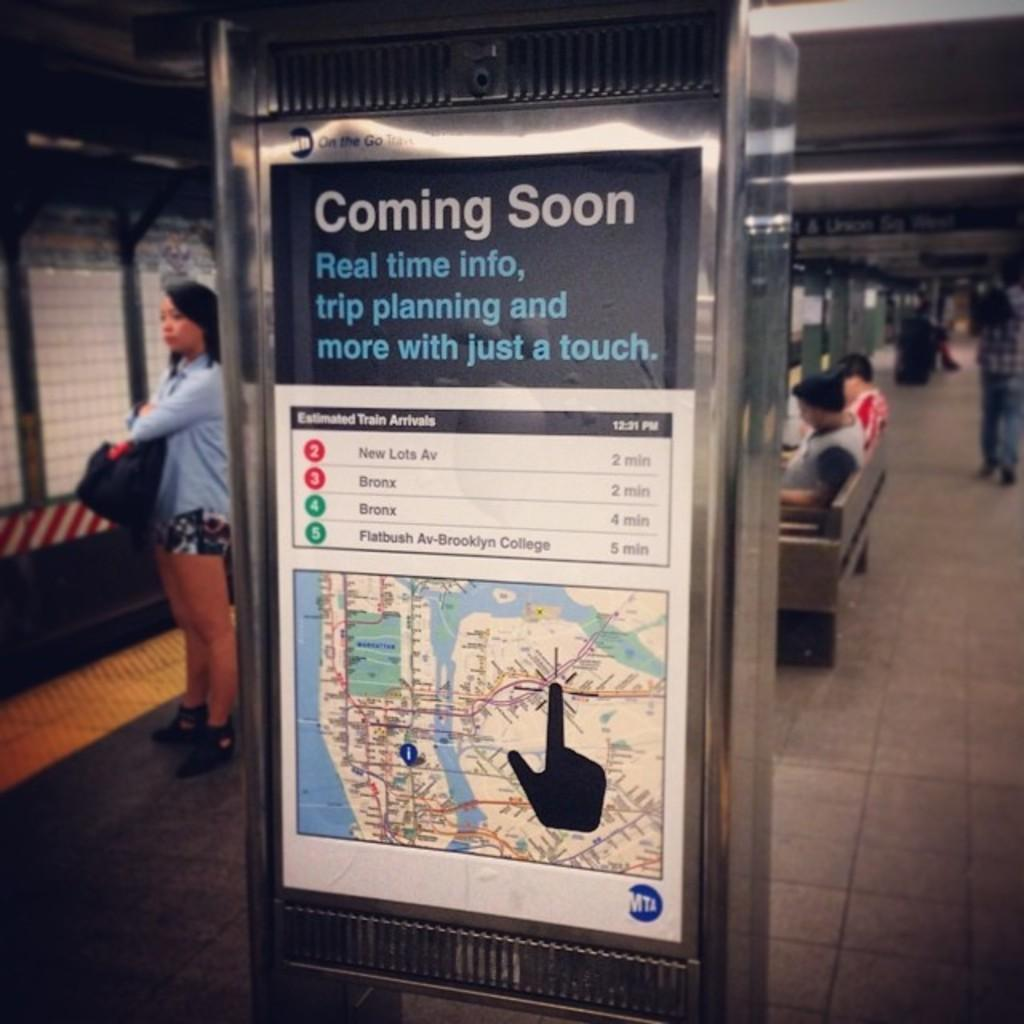<image>
Create a compact narrative representing the image presented. the real time info for the trains is coming soon 